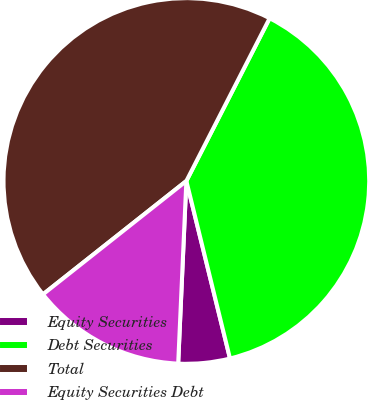Convert chart. <chart><loc_0><loc_0><loc_500><loc_500><pie_chart><fcel>Equity Securities<fcel>Debt Securities<fcel>Total<fcel>Equity Securities Debt<nl><fcel>4.55%<fcel>38.64%<fcel>43.18%<fcel>13.64%<nl></chart> 